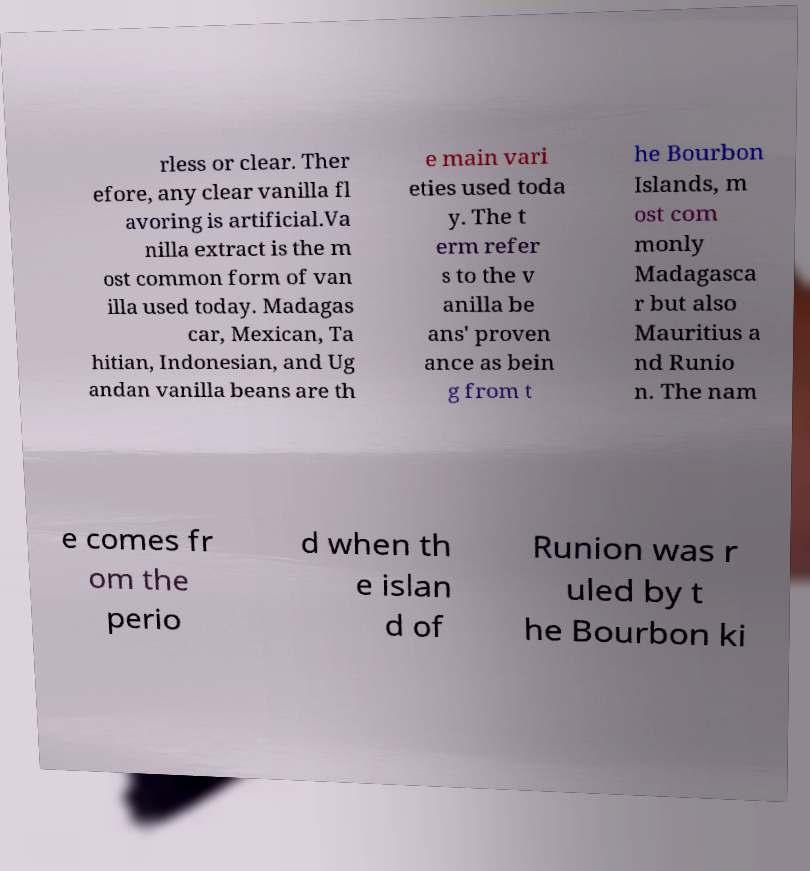Can you accurately transcribe the text from the provided image for me? rless or clear. Ther efore, any clear vanilla fl avoring is artificial.Va nilla extract is the m ost common form of van illa used today. Madagas car, Mexican, Ta hitian, Indonesian, and Ug andan vanilla beans are th e main vari eties used toda y. The t erm refer s to the v anilla be ans' proven ance as bein g from t he Bourbon Islands, m ost com monly Madagasca r but also Mauritius a nd Runio n. The nam e comes fr om the perio d when th e islan d of Runion was r uled by t he Bourbon ki 